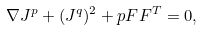Convert formula to latex. <formula><loc_0><loc_0><loc_500><loc_500>\nabla J ^ { p } + ( J ^ { q } ) ^ { 2 } + p F F ^ { T } = 0 ,</formula> 